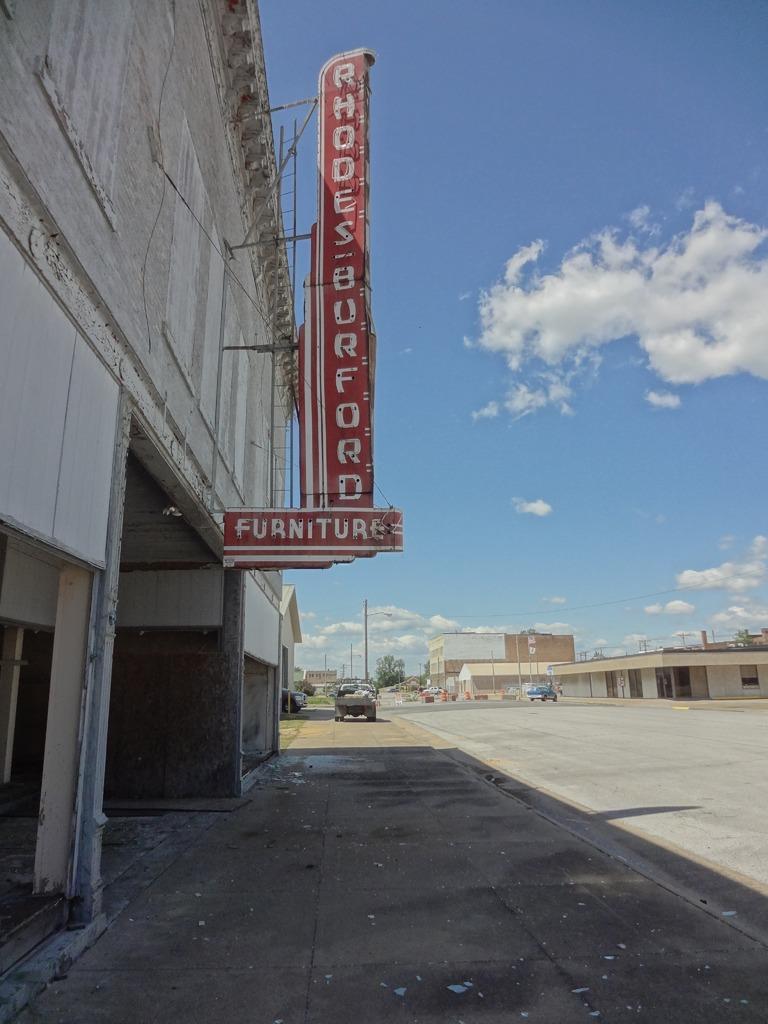Could you give a brief overview of what you see in this image? In this image I can see the vehicle on the road. To the left I can see the vehicles and the buildings with boards. In the background I can see few more buildings, poles, trees, clouds and the sky. 